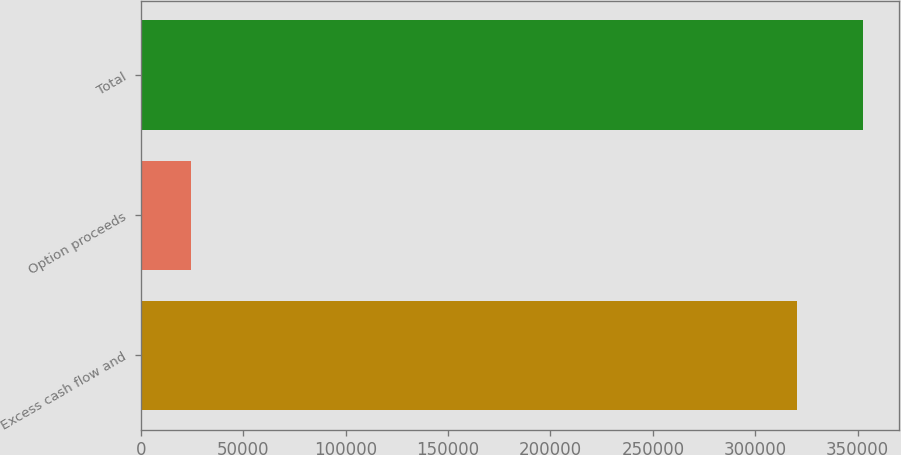Convert chart. <chart><loc_0><loc_0><loc_500><loc_500><bar_chart><fcel>Excess cash flow and<fcel>Option proceeds<fcel>Total<nl><fcel>320425<fcel>24436<fcel>352468<nl></chart> 